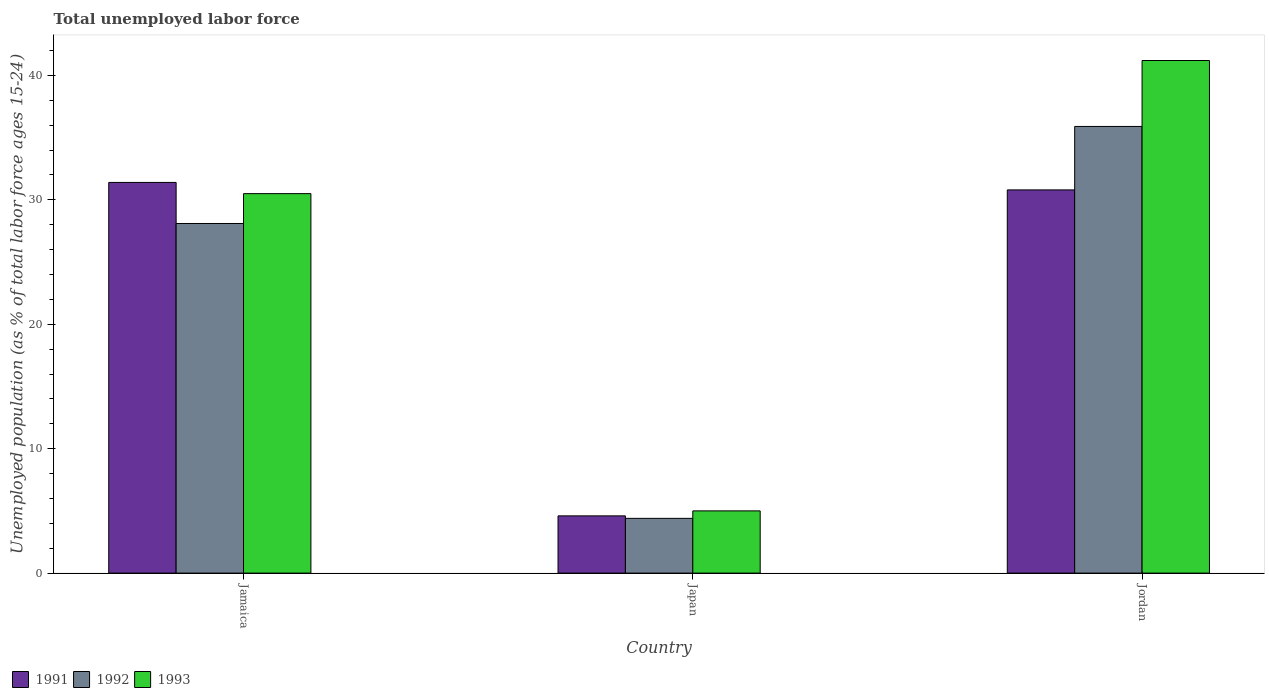How many groups of bars are there?
Your answer should be compact. 3. Are the number of bars per tick equal to the number of legend labels?
Your answer should be compact. Yes. How many bars are there on the 3rd tick from the left?
Keep it short and to the point. 3. How many bars are there on the 2nd tick from the right?
Your answer should be compact. 3. What is the label of the 2nd group of bars from the left?
Your response must be concise. Japan. Across all countries, what is the maximum percentage of unemployed population in in 1991?
Your answer should be very brief. 31.4. Across all countries, what is the minimum percentage of unemployed population in in 1991?
Offer a terse response. 4.6. In which country was the percentage of unemployed population in in 1993 maximum?
Keep it short and to the point. Jordan. In which country was the percentage of unemployed population in in 1991 minimum?
Your response must be concise. Japan. What is the total percentage of unemployed population in in 1992 in the graph?
Make the answer very short. 68.4. What is the difference between the percentage of unemployed population in in 1991 in Jamaica and that in Japan?
Your response must be concise. 26.8. What is the difference between the percentage of unemployed population in in 1992 in Jordan and the percentage of unemployed population in in 1991 in Jamaica?
Provide a succinct answer. 4.5. What is the average percentage of unemployed population in in 1991 per country?
Give a very brief answer. 22.27. What is the difference between the percentage of unemployed population in of/in 1992 and percentage of unemployed population in of/in 1991 in Jordan?
Give a very brief answer. 5.1. In how many countries, is the percentage of unemployed population in in 1991 greater than 34 %?
Your answer should be compact. 0. What is the ratio of the percentage of unemployed population in in 1993 in Japan to that in Jordan?
Provide a succinct answer. 0.12. What is the difference between the highest and the second highest percentage of unemployed population in in 1991?
Keep it short and to the point. -26.2. What is the difference between the highest and the lowest percentage of unemployed population in in 1993?
Ensure brevity in your answer.  36.2. What does the 3rd bar from the left in Jamaica represents?
Provide a succinct answer. 1993. Are all the bars in the graph horizontal?
Give a very brief answer. No. How many countries are there in the graph?
Provide a short and direct response. 3. What is the difference between two consecutive major ticks on the Y-axis?
Ensure brevity in your answer.  10. Does the graph contain any zero values?
Your answer should be compact. No. Does the graph contain grids?
Provide a succinct answer. No. How are the legend labels stacked?
Provide a short and direct response. Horizontal. What is the title of the graph?
Keep it short and to the point. Total unemployed labor force. Does "1962" appear as one of the legend labels in the graph?
Give a very brief answer. No. What is the label or title of the Y-axis?
Ensure brevity in your answer.  Unemployed population (as % of total labor force ages 15-24). What is the Unemployed population (as % of total labor force ages 15-24) in 1991 in Jamaica?
Offer a very short reply. 31.4. What is the Unemployed population (as % of total labor force ages 15-24) in 1992 in Jamaica?
Provide a succinct answer. 28.1. What is the Unemployed population (as % of total labor force ages 15-24) of 1993 in Jamaica?
Your answer should be very brief. 30.5. What is the Unemployed population (as % of total labor force ages 15-24) in 1991 in Japan?
Your answer should be very brief. 4.6. What is the Unemployed population (as % of total labor force ages 15-24) of 1992 in Japan?
Make the answer very short. 4.4. What is the Unemployed population (as % of total labor force ages 15-24) of 1991 in Jordan?
Offer a very short reply. 30.8. What is the Unemployed population (as % of total labor force ages 15-24) of 1992 in Jordan?
Make the answer very short. 35.9. What is the Unemployed population (as % of total labor force ages 15-24) in 1993 in Jordan?
Offer a terse response. 41.2. Across all countries, what is the maximum Unemployed population (as % of total labor force ages 15-24) in 1991?
Give a very brief answer. 31.4. Across all countries, what is the maximum Unemployed population (as % of total labor force ages 15-24) in 1992?
Keep it short and to the point. 35.9. Across all countries, what is the maximum Unemployed population (as % of total labor force ages 15-24) in 1993?
Provide a short and direct response. 41.2. Across all countries, what is the minimum Unemployed population (as % of total labor force ages 15-24) of 1991?
Make the answer very short. 4.6. Across all countries, what is the minimum Unemployed population (as % of total labor force ages 15-24) of 1992?
Keep it short and to the point. 4.4. What is the total Unemployed population (as % of total labor force ages 15-24) in 1991 in the graph?
Your answer should be compact. 66.8. What is the total Unemployed population (as % of total labor force ages 15-24) of 1992 in the graph?
Provide a succinct answer. 68.4. What is the total Unemployed population (as % of total labor force ages 15-24) in 1993 in the graph?
Make the answer very short. 76.7. What is the difference between the Unemployed population (as % of total labor force ages 15-24) in 1991 in Jamaica and that in Japan?
Offer a terse response. 26.8. What is the difference between the Unemployed population (as % of total labor force ages 15-24) in 1992 in Jamaica and that in Japan?
Keep it short and to the point. 23.7. What is the difference between the Unemployed population (as % of total labor force ages 15-24) of 1991 in Jamaica and that in Jordan?
Offer a very short reply. 0.6. What is the difference between the Unemployed population (as % of total labor force ages 15-24) in 1991 in Japan and that in Jordan?
Offer a terse response. -26.2. What is the difference between the Unemployed population (as % of total labor force ages 15-24) in 1992 in Japan and that in Jordan?
Your answer should be compact. -31.5. What is the difference between the Unemployed population (as % of total labor force ages 15-24) in 1993 in Japan and that in Jordan?
Give a very brief answer. -36.2. What is the difference between the Unemployed population (as % of total labor force ages 15-24) in 1991 in Jamaica and the Unemployed population (as % of total labor force ages 15-24) in 1992 in Japan?
Ensure brevity in your answer.  27. What is the difference between the Unemployed population (as % of total labor force ages 15-24) of 1991 in Jamaica and the Unemployed population (as % of total labor force ages 15-24) of 1993 in Japan?
Make the answer very short. 26.4. What is the difference between the Unemployed population (as % of total labor force ages 15-24) in 1992 in Jamaica and the Unemployed population (as % of total labor force ages 15-24) in 1993 in Japan?
Offer a very short reply. 23.1. What is the difference between the Unemployed population (as % of total labor force ages 15-24) of 1991 in Jamaica and the Unemployed population (as % of total labor force ages 15-24) of 1992 in Jordan?
Provide a short and direct response. -4.5. What is the difference between the Unemployed population (as % of total labor force ages 15-24) of 1991 in Jamaica and the Unemployed population (as % of total labor force ages 15-24) of 1993 in Jordan?
Provide a short and direct response. -9.8. What is the difference between the Unemployed population (as % of total labor force ages 15-24) of 1992 in Jamaica and the Unemployed population (as % of total labor force ages 15-24) of 1993 in Jordan?
Your answer should be compact. -13.1. What is the difference between the Unemployed population (as % of total labor force ages 15-24) of 1991 in Japan and the Unemployed population (as % of total labor force ages 15-24) of 1992 in Jordan?
Offer a terse response. -31.3. What is the difference between the Unemployed population (as % of total labor force ages 15-24) in 1991 in Japan and the Unemployed population (as % of total labor force ages 15-24) in 1993 in Jordan?
Offer a very short reply. -36.6. What is the difference between the Unemployed population (as % of total labor force ages 15-24) in 1992 in Japan and the Unemployed population (as % of total labor force ages 15-24) in 1993 in Jordan?
Your response must be concise. -36.8. What is the average Unemployed population (as % of total labor force ages 15-24) of 1991 per country?
Offer a terse response. 22.27. What is the average Unemployed population (as % of total labor force ages 15-24) in 1992 per country?
Your answer should be compact. 22.8. What is the average Unemployed population (as % of total labor force ages 15-24) of 1993 per country?
Your answer should be very brief. 25.57. What is the difference between the Unemployed population (as % of total labor force ages 15-24) of 1991 and Unemployed population (as % of total labor force ages 15-24) of 1992 in Jamaica?
Your answer should be very brief. 3.3. What is the difference between the Unemployed population (as % of total labor force ages 15-24) in 1992 and Unemployed population (as % of total labor force ages 15-24) in 1993 in Jamaica?
Keep it short and to the point. -2.4. What is the difference between the Unemployed population (as % of total labor force ages 15-24) of 1992 and Unemployed population (as % of total labor force ages 15-24) of 1993 in Japan?
Your answer should be compact. -0.6. What is the difference between the Unemployed population (as % of total labor force ages 15-24) of 1991 and Unemployed population (as % of total labor force ages 15-24) of 1992 in Jordan?
Your response must be concise. -5.1. What is the ratio of the Unemployed population (as % of total labor force ages 15-24) in 1991 in Jamaica to that in Japan?
Offer a very short reply. 6.83. What is the ratio of the Unemployed population (as % of total labor force ages 15-24) of 1992 in Jamaica to that in Japan?
Keep it short and to the point. 6.39. What is the ratio of the Unemployed population (as % of total labor force ages 15-24) in 1993 in Jamaica to that in Japan?
Your response must be concise. 6.1. What is the ratio of the Unemployed population (as % of total labor force ages 15-24) of 1991 in Jamaica to that in Jordan?
Give a very brief answer. 1.02. What is the ratio of the Unemployed population (as % of total labor force ages 15-24) of 1992 in Jamaica to that in Jordan?
Give a very brief answer. 0.78. What is the ratio of the Unemployed population (as % of total labor force ages 15-24) in 1993 in Jamaica to that in Jordan?
Offer a terse response. 0.74. What is the ratio of the Unemployed population (as % of total labor force ages 15-24) of 1991 in Japan to that in Jordan?
Your answer should be compact. 0.15. What is the ratio of the Unemployed population (as % of total labor force ages 15-24) in 1992 in Japan to that in Jordan?
Ensure brevity in your answer.  0.12. What is the ratio of the Unemployed population (as % of total labor force ages 15-24) of 1993 in Japan to that in Jordan?
Your answer should be very brief. 0.12. What is the difference between the highest and the lowest Unemployed population (as % of total labor force ages 15-24) of 1991?
Offer a terse response. 26.8. What is the difference between the highest and the lowest Unemployed population (as % of total labor force ages 15-24) of 1992?
Keep it short and to the point. 31.5. What is the difference between the highest and the lowest Unemployed population (as % of total labor force ages 15-24) in 1993?
Make the answer very short. 36.2. 